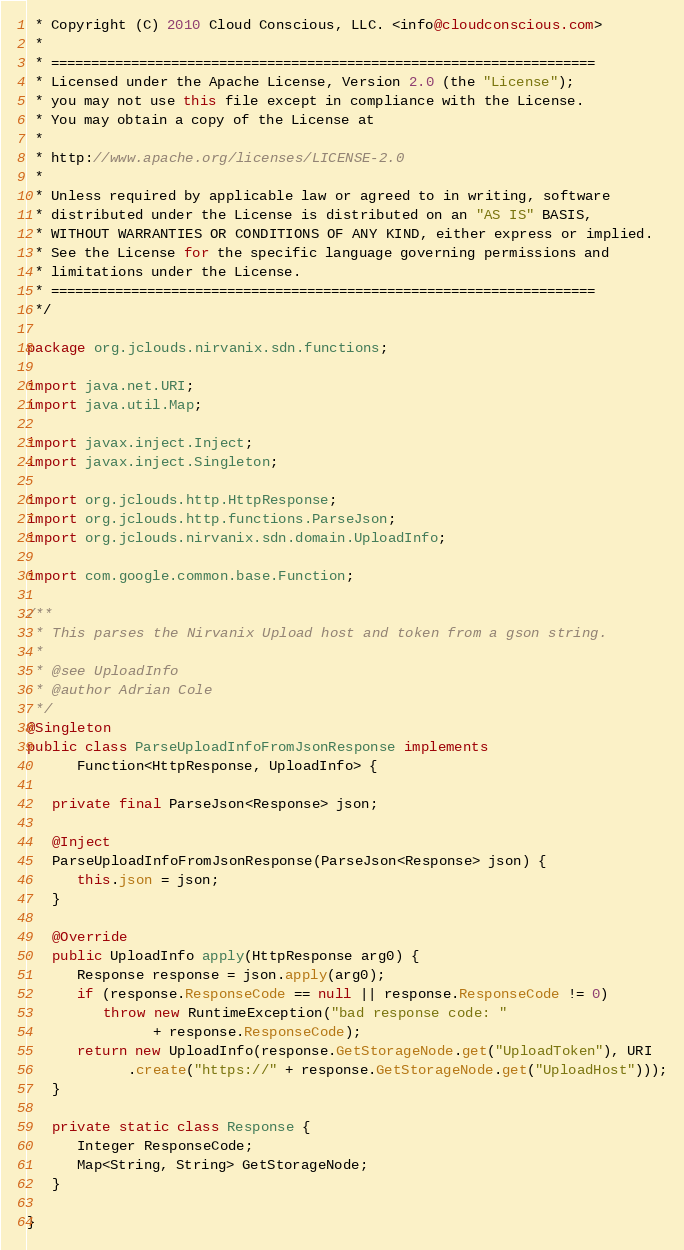<code> <loc_0><loc_0><loc_500><loc_500><_Java_> * Copyright (C) 2010 Cloud Conscious, LLC. <info@cloudconscious.com>
 *
 * ====================================================================
 * Licensed under the Apache License, Version 2.0 (the "License");
 * you may not use this file except in compliance with the License.
 * You may obtain a copy of the License at
 *
 * http://www.apache.org/licenses/LICENSE-2.0
 *
 * Unless required by applicable law or agreed to in writing, software
 * distributed under the License is distributed on an "AS IS" BASIS,
 * WITHOUT WARRANTIES OR CONDITIONS OF ANY KIND, either express or implied.
 * See the License for the specific language governing permissions and
 * limitations under the License.
 * ====================================================================
 */

package org.jclouds.nirvanix.sdn.functions;

import java.net.URI;
import java.util.Map;

import javax.inject.Inject;
import javax.inject.Singleton;

import org.jclouds.http.HttpResponse;
import org.jclouds.http.functions.ParseJson;
import org.jclouds.nirvanix.sdn.domain.UploadInfo;

import com.google.common.base.Function;

/**
 * This parses the Nirvanix Upload host and token from a gson string.
 * 
 * @see UploadInfo
 * @author Adrian Cole
 */
@Singleton
public class ParseUploadInfoFromJsonResponse implements
      Function<HttpResponse, UploadInfo> {

   private final ParseJson<Response> json;

   @Inject
   ParseUploadInfoFromJsonResponse(ParseJson<Response> json) {
      this.json = json;
   }

   @Override
   public UploadInfo apply(HttpResponse arg0) {
      Response response = json.apply(arg0);
      if (response.ResponseCode == null || response.ResponseCode != 0)
         throw new RuntimeException("bad response code: "
               + response.ResponseCode);
      return new UploadInfo(response.GetStorageNode.get("UploadToken"), URI
            .create("https://" + response.GetStorageNode.get("UploadHost")));
   }

   private static class Response {
      Integer ResponseCode;
      Map<String, String> GetStorageNode;
   }

}</code> 